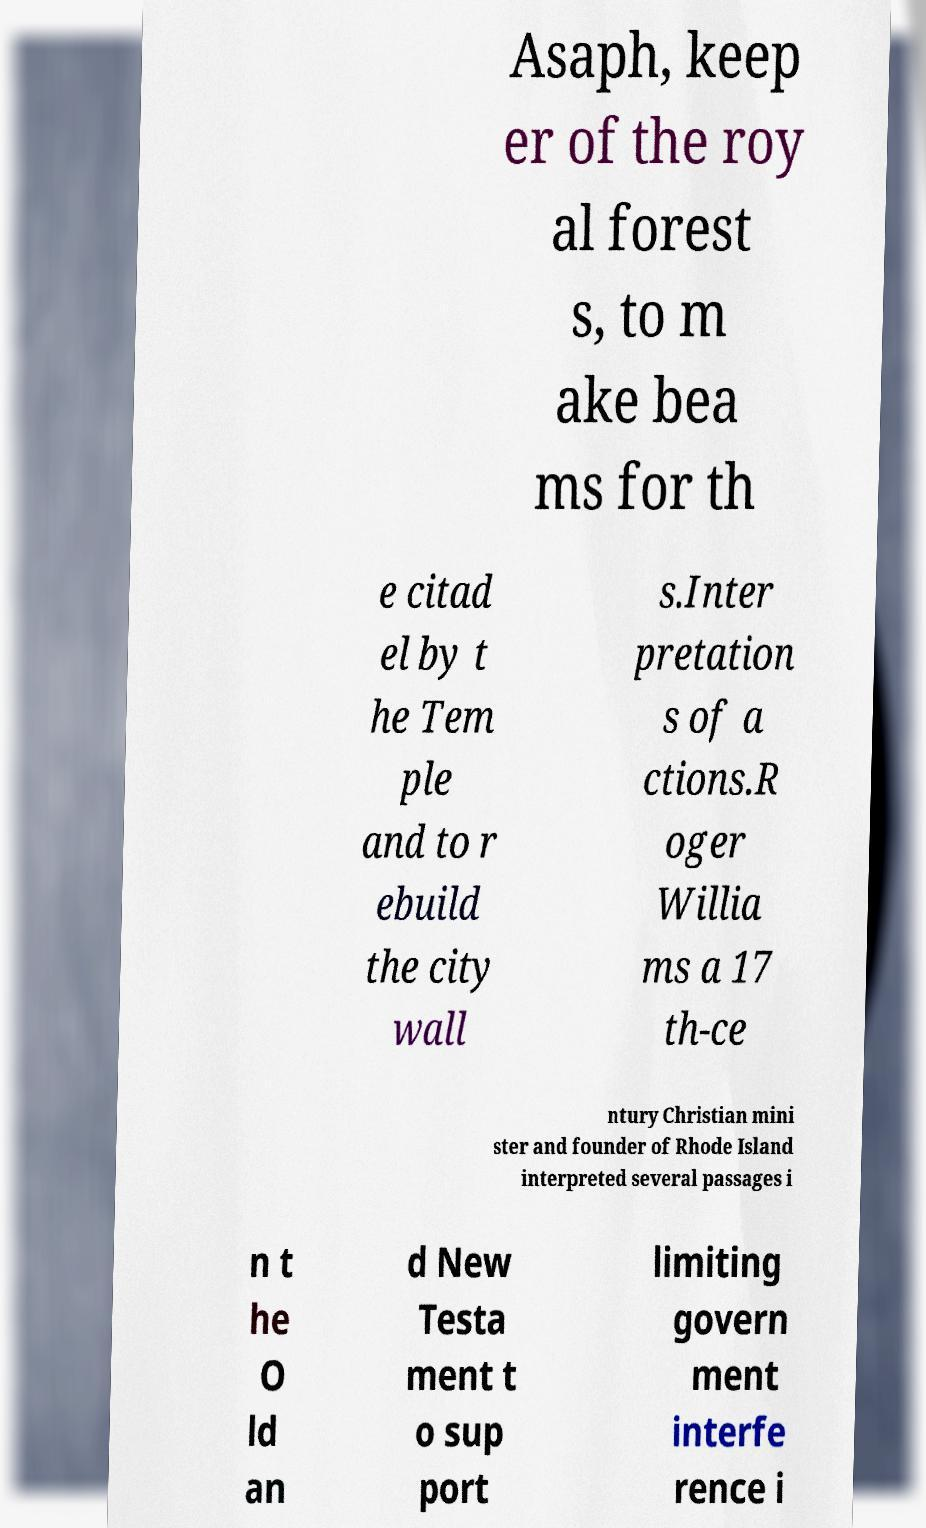Please read and relay the text visible in this image. What does it say? Asaph, keep er of the roy al forest s, to m ake bea ms for th e citad el by t he Tem ple and to r ebuild the city wall s.Inter pretation s of a ctions.R oger Willia ms a 17 th-ce ntury Christian mini ster and founder of Rhode Island interpreted several passages i n t he O ld an d New Testa ment t o sup port limiting govern ment interfe rence i 